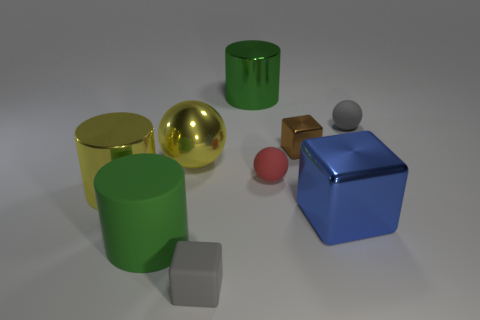What is the shape of the tiny thing that is the same color as the rubber cube?
Offer a very short reply. Sphere. Is the shape of the tiny rubber thing in front of the red sphere the same as the brown thing behind the big shiny ball?
Keep it short and to the point. Yes. What number of objects are gray shiny spheres or big green cylinders that are behind the small shiny cube?
Ensure brevity in your answer.  1. There is a large thing that is both behind the tiny red thing and on the left side of the green shiny cylinder; what material is it?
Provide a short and direct response. Metal. There is a tiny ball that is the same material as the red thing; what color is it?
Offer a very short reply. Gray. What number of objects are either large gray shiny blocks or small objects?
Keep it short and to the point. 4. Does the gray matte block have the same size as the cylinder that is right of the tiny rubber block?
Your answer should be very brief. No. What is the color of the cylinder right of the tiny block that is in front of the green object left of the large yellow metal sphere?
Offer a terse response. Green. The big ball is what color?
Ensure brevity in your answer.  Yellow. Are there more blue objects left of the small gray cube than small shiny things that are behind the gray matte sphere?
Your answer should be compact. No. 